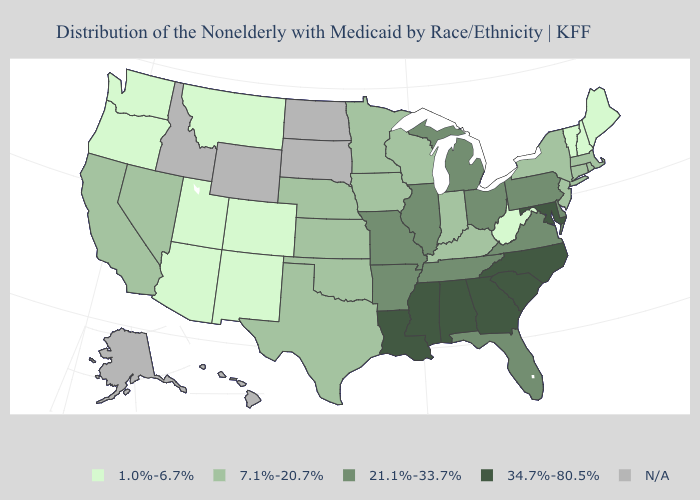Name the states that have a value in the range N/A?
Be succinct. Alaska, Hawaii, Idaho, North Dakota, South Dakota, Wyoming. Name the states that have a value in the range 34.7%-80.5%?
Keep it brief. Alabama, Georgia, Louisiana, Maryland, Mississippi, North Carolina, South Carolina. What is the lowest value in states that border New Mexico?
Quick response, please. 1.0%-6.7%. Does the first symbol in the legend represent the smallest category?
Be succinct. Yes. What is the value of Connecticut?
Keep it brief. 7.1%-20.7%. Among the states that border Iowa , does Missouri have the highest value?
Short answer required. Yes. Does the map have missing data?
Quick response, please. Yes. What is the value of Arizona?
Be succinct. 1.0%-6.7%. Which states have the highest value in the USA?
Give a very brief answer. Alabama, Georgia, Louisiana, Maryland, Mississippi, North Carolina, South Carolina. How many symbols are there in the legend?
Keep it brief. 5. Name the states that have a value in the range 21.1%-33.7%?
Answer briefly. Arkansas, Delaware, Florida, Illinois, Michigan, Missouri, Ohio, Pennsylvania, Tennessee, Virginia. Does Oregon have the lowest value in the USA?
Concise answer only. Yes. What is the value of Alaska?
Give a very brief answer. N/A. What is the lowest value in the West?
Answer briefly. 1.0%-6.7%. Which states have the highest value in the USA?
Answer briefly. Alabama, Georgia, Louisiana, Maryland, Mississippi, North Carolina, South Carolina. 